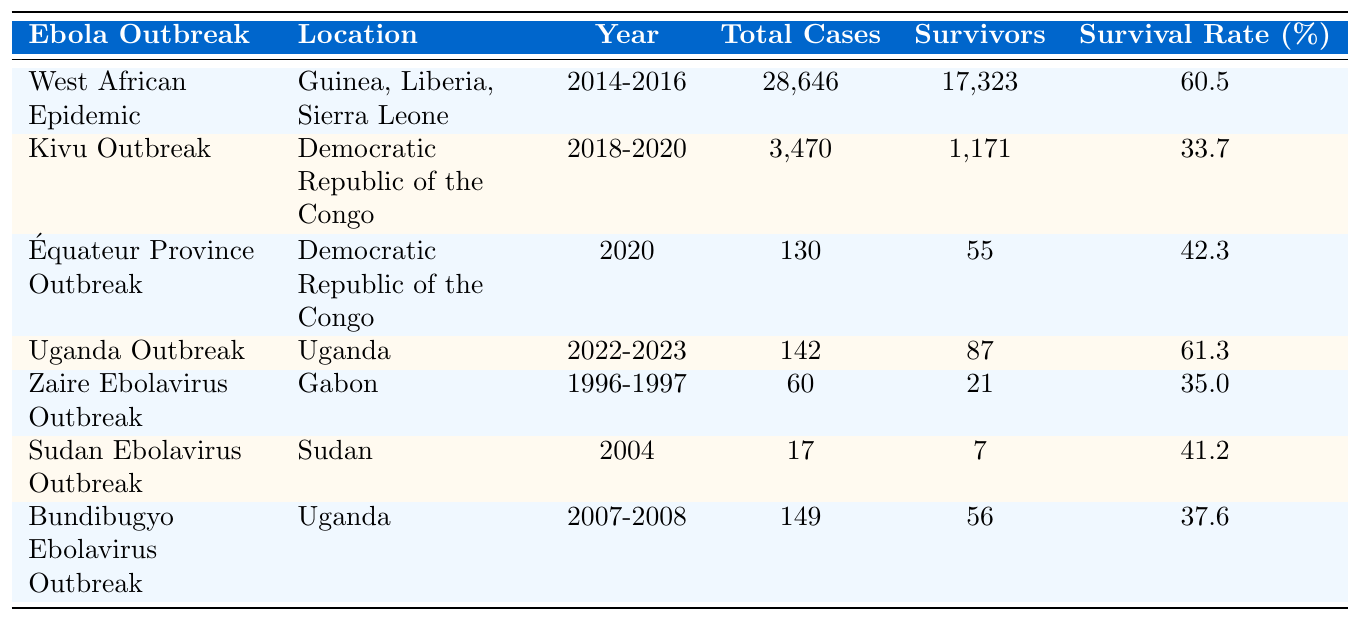What is the survival rate of the West African Epidemic? The table lists the survival rate for the West African Epidemic as 60.5%.
Answer: 60.5% In which year did the Uganda Outbreak occur? The table indicates that the Uganda Outbreak took place between 2022 and 2023.
Answer: 2022-2023 How many total cases were reported in the Zaire Ebolavirus Outbreak? The total cases for the Zaire Ebolavirus Outbreak, as shown in the table, are 60.
Answer: 60 Which outbreak had the lowest survival rate? By examining the survival rates in the table, the Kivu Outbreak has the lowest survival rate at 33.7%.
Answer: 33.7% What is the total number of survivors across all the outbreaks? Summing the number of survivors from each outbreak: 17323 (West African) + 1171 (Kivu) + 55 (Équateur) + 87 (Uganda) + 21 (Zaire) + 7 (Sudan) + 56 (Bundibugyo) gives 18620 survivors in total.
Answer: 18620 Did the Équateur Province Outbreak have a higher survival rate than the Sudan Ebolavirus Outbreak? The survival rate for the Équateur Province Outbreak is 42.3%, while the Sudan Ebolavirus Outbreak has a survival rate of 41.2%. Since 42.3% > 41.2%, the statement is true.
Answer: Yes What is the difference in survival rates between the West African Epidemic and the Kivu Outbreak? The survival rate for the West African Epidemic is 60.5% and for the Kivu Outbreak is 33.7%. The difference is 60.5% - 33.7% = 26.8%.
Answer: 26.8% How many outbreaks had a survival rate greater than 40%? The table shows that the West African Epidemic, Uganda Outbreak, and Équateur Province Outbreak have survival rates exceeding 40%. That counts as three outbreaks.
Answer: 3 What percentage of total cases were survivors in the Bundibugyo Ebolavirus Outbreak? The table shows 149 total cases with 56 survivors. The survival percentage is (56 / 149) * 100 = approximately 37.6%.
Answer: 37.6% Which location had the highest number of total reported cases? The West African Epidemic has the highest total cases reported with 28646 cases.
Answer: Guinea, Liberia, Sierra Leone What is the average survival rate across all listed outbreaks? The survival rates from the table are: 60.5, 33.7, 42.3, 61.3, 35.0, 41.2, and 37.6. The average is calculated by summing them (60.5 + 33.7 + 42.3 + 61.3 + 35.0 + 41.2 + 37.6 = 311.6) and dividing by 7 (311.6 / 7 = 44.0).
Answer: 44.0 